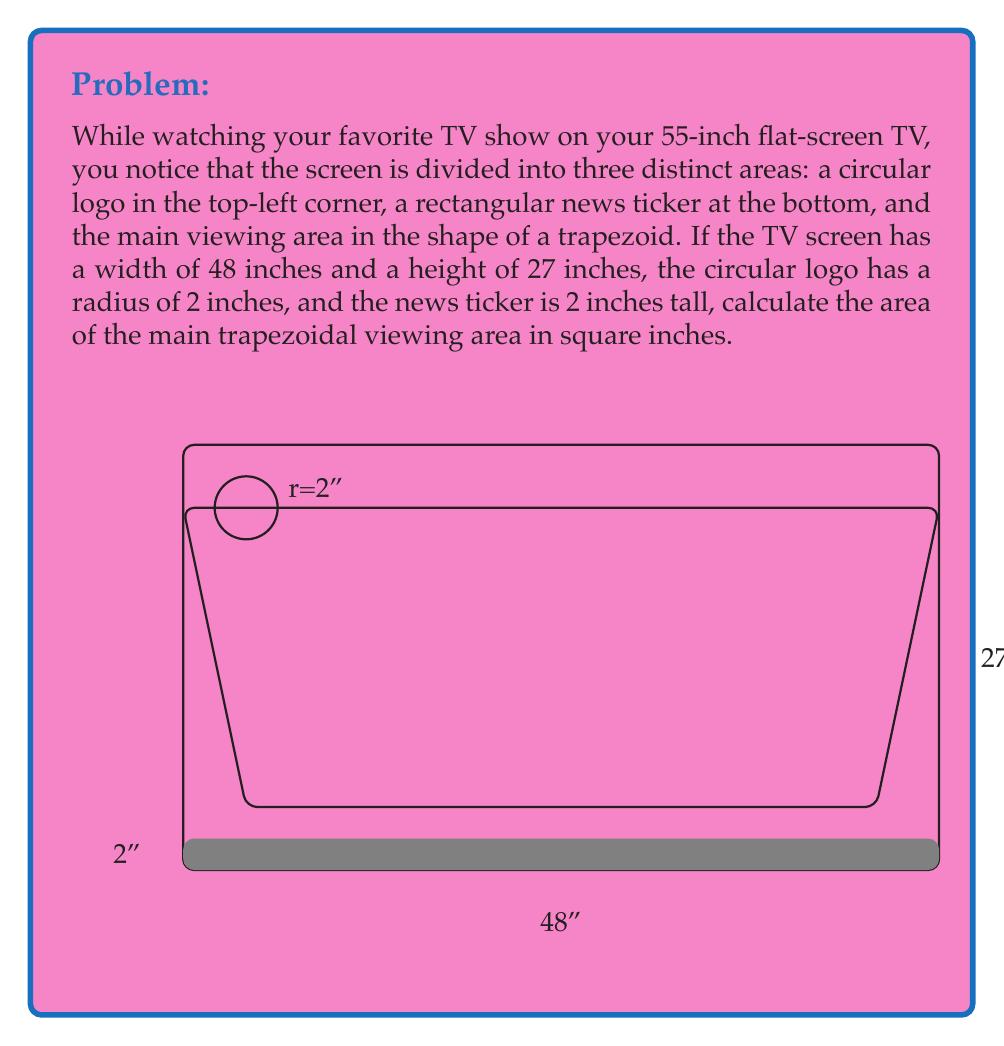Teach me how to tackle this problem. Let's solve this problem step by step:

1) First, calculate the total area of the TV screen:
   $A_{total} = 48 \text{ inches} \times 27 \text{ inches} = 1296 \text{ sq inches}$

2) Calculate the area of the circular logo:
   $A_{logo} = \pi r^2 = \pi (2 \text{ inches})^2 = 4\pi \text{ sq inches}$

3) Calculate the area of the rectangular news ticker:
   $A_{ticker} = 48 \text{ inches} \times 2 \text{ inches} = 96 \text{ sq inches}$

4) The area of the main viewing area (trapezoid) is the total area minus the areas of the logo and ticker:
   $A_{main} = A_{total} - A_{logo} - A_{ticker}$
   $A_{main} = 1296 - 4\pi - 96$

5) Simplify:
   $A_{main} = 1200 - 4\pi \text{ sq inches}$

6) Calculate the approximate value:
   $A_{main} \approx 1200 - 4(3.14159) \approx 1187.37 \text{ sq inches}$

Therefore, the area of the main trapezoidal viewing area is approximately 1187.37 square inches.
Answer: $1200 - 4\pi \text{ sq inches} \approx 1187.37 \text{ sq inches}$ 